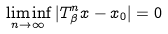Convert formula to latex. <formula><loc_0><loc_0><loc_500><loc_500>\liminf _ { n \to \infty } | T _ { \beta } ^ { n } x - x _ { 0 } | = 0</formula> 